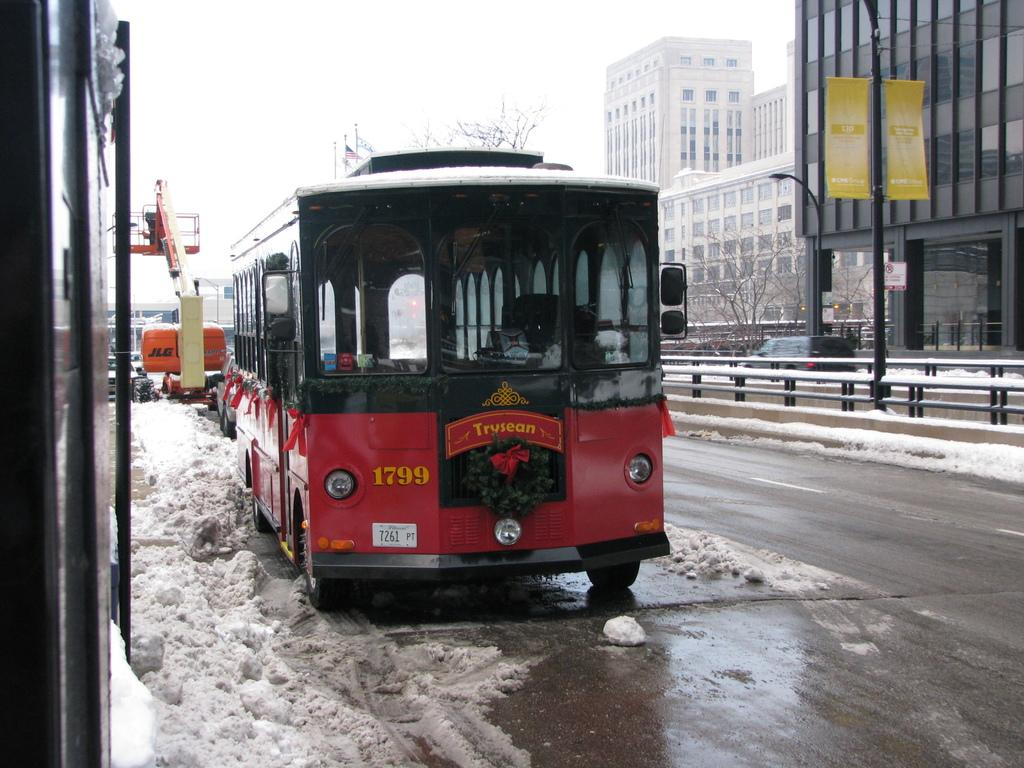<image>
Offer a succinct explanation of the picture presented. A red bus with the letters 1799 on the bottom left in yellow 